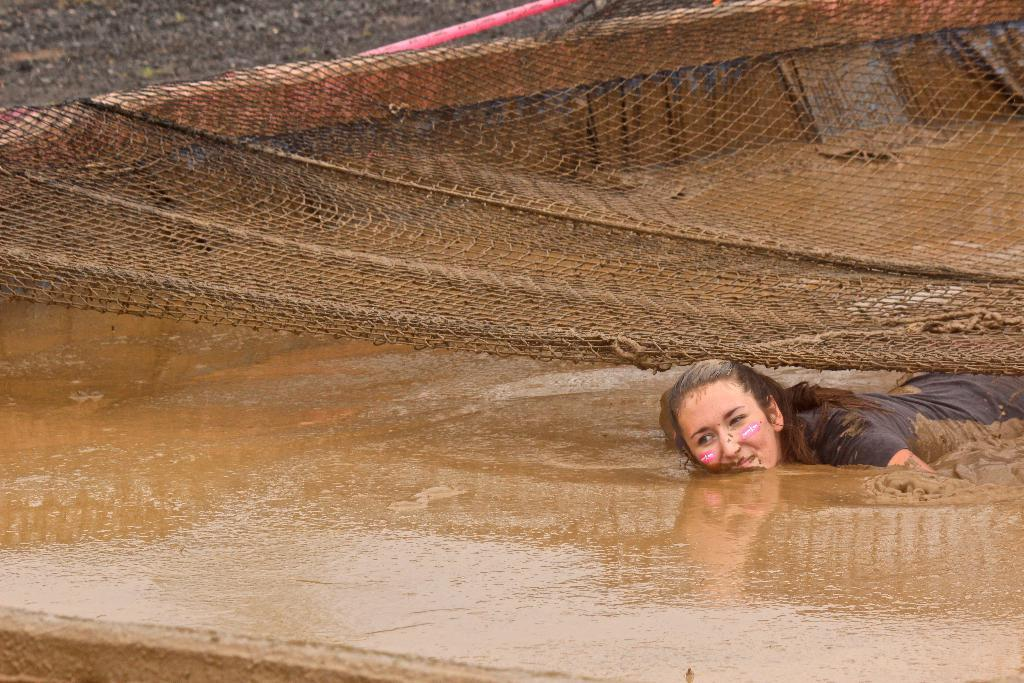Who is the main subject in the image? There is a woman in the image. What is the woman doing in the image? The woman is swimming in mud. What is above the woman in the image? There is a net above the woman. What type of objects can be seen in the image? There are wooden objects in the image. What type of chalk is the woman using to draw in the image? There is no chalk present in the image, and the woman is swimming in mud, not drawing. 